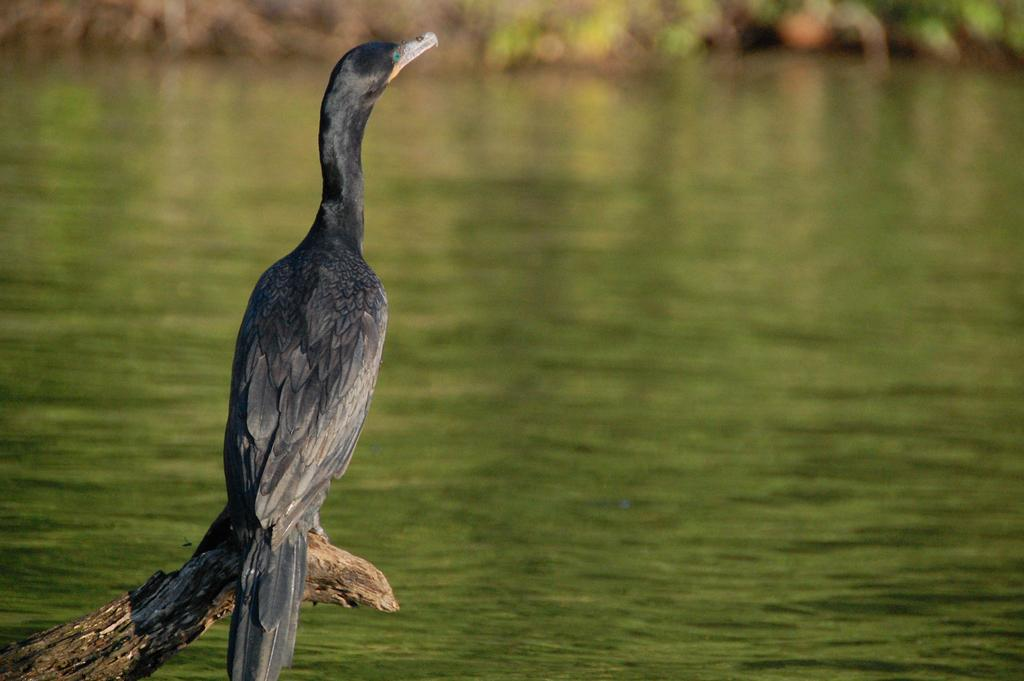What type of animal is in the image? There is a bird in the image. Where is the bird located? The bird is on a wood log. What can be seen at the bottom of the image? There is water visible at the bottom of the image. What is visible at the top of the image? There are plants visible at the top of the image. What type of appliance can be seen in the image? There is no appliance present in the image. Is there a bike visible in the image? There is no bike present in the image. 